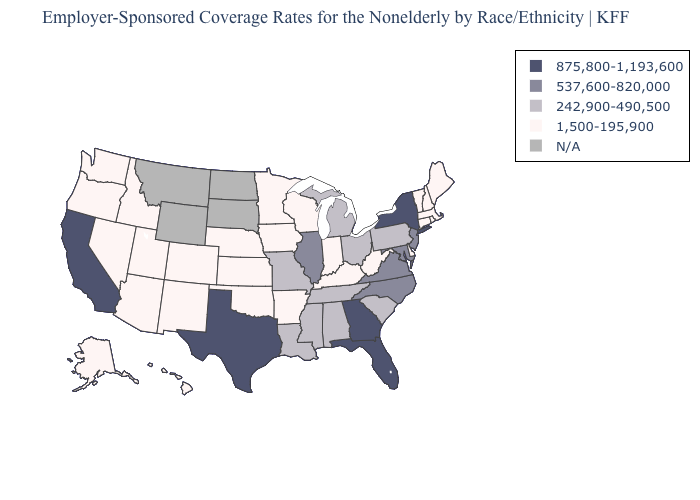Among the states that border Mississippi , which have the highest value?
Write a very short answer. Alabama, Louisiana, Tennessee. What is the value of Wyoming?
Keep it brief. N/A. Name the states that have a value in the range 242,900-490,500?
Answer briefly. Alabama, Louisiana, Michigan, Mississippi, Missouri, Ohio, Pennsylvania, South Carolina, Tennessee. Among the states that border Pennsylvania , does Delaware have the highest value?
Keep it brief. No. Does the map have missing data?
Keep it brief. Yes. What is the value of California?
Short answer required. 875,800-1,193,600. Does the map have missing data?
Be succinct. Yes. What is the value of Colorado?
Give a very brief answer. 1,500-195,900. What is the highest value in the Northeast ?
Quick response, please. 875,800-1,193,600. What is the lowest value in states that border Kansas?
Be succinct. 1,500-195,900. Does the map have missing data?
Short answer required. Yes. Which states have the lowest value in the MidWest?
Write a very short answer. Indiana, Iowa, Kansas, Minnesota, Nebraska, Wisconsin. What is the value of California?
Give a very brief answer. 875,800-1,193,600. What is the highest value in the Northeast ?
Be succinct. 875,800-1,193,600. 